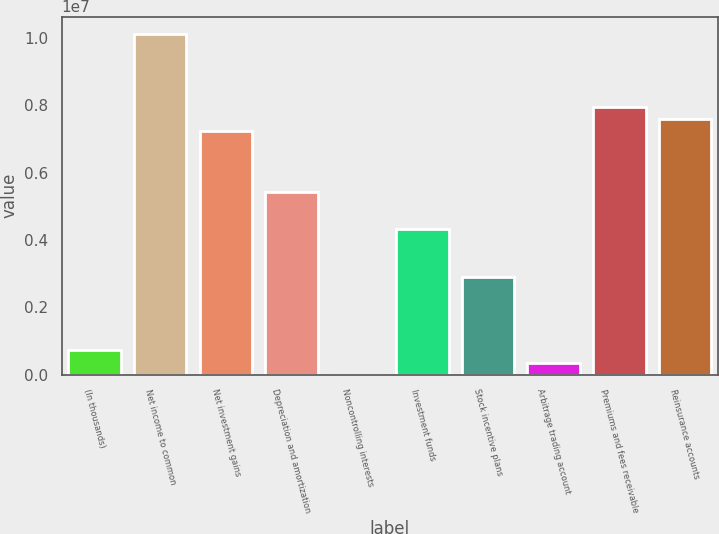Convert chart. <chart><loc_0><loc_0><loc_500><loc_500><bar_chart><fcel>(In thousands)<fcel>Net income to common<fcel>Net investment gains<fcel>Depreciation and amortization<fcel>Noncontrolling interests<fcel>Investment funds<fcel>Stock incentive plans<fcel>Arbitrage trading account<fcel>Premiums and fees receivable<fcel>Reinsurance accounts<nl><fcel>723441<fcel>1.01275e+07<fcel>7.23395e+06<fcel>5.42548e+06<fcel>51<fcel>4.34039e+06<fcel>2.89361e+06<fcel>361746<fcel>7.95734e+06<fcel>7.59565e+06<nl></chart> 